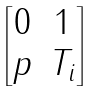<formula> <loc_0><loc_0><loc_500><loc_500>\begin{bmatrix} 0 & 1 \\ p & T _ { i } \end{bmatrix}</formula> 